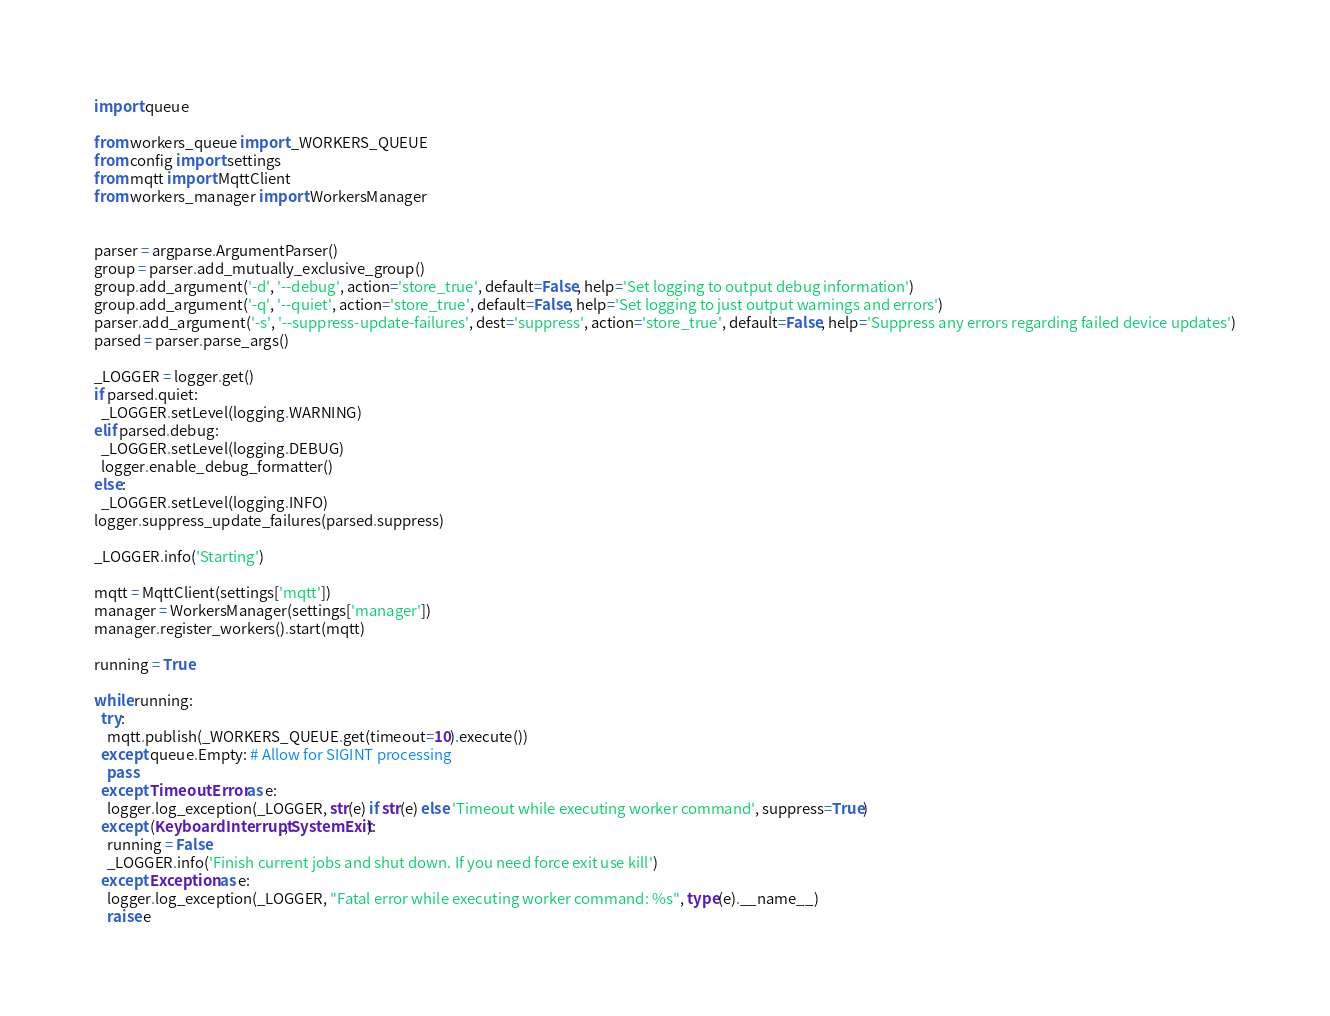<code> <loc_0><loc_0><loc_500><loc_500><_Python_>import queue

from workers_queue import _WORKERS_QUEUE
from config import settings
from mqtt import MqttClient
from workers_manager import WorkersManager


parser = argparse.ArgumentParser()
group = parser.add_mutually_exclusive_group()
group.add_argument('-d', '--debug', action='store_true', default=False, help='Set logging to output debug information')
group.add_argument('-q', '--quiet', action='store_true', default=False, help='Set logging to just output warnings and errors')
parser.add_argument('-s', '--suppress-update-failures', dest='suppress', action='store_true', default=False, help='Suppress any errors regarding failed device updates')
parsed = parser.parse_args()

_LOGGER = logger.get()
if parsed.quiet:
  _LOGGER.setLevel(logging.WARNING)
elif parsed.debug:
  _LOGGER.setLevel(logging.DEBUG)
  logger.enable_debug_formatter()
else:
  _LOGGER.setLevel(logging.INFO)
logger.suppress_update_failures(parsed.suppress)

_LOGGER.info('Starting')

mqtt = MqttClient(settings['mqtt'])
manager = WorkersManager(settings['manager'])
manager.register_workers().start(mqtt)

running = True

while running:
  try:
    mqtt.publish(_WORKERS_QUEUE.get(timeout=10).execute())
  except queue.Empty: # Allow for SIGINT processing
    pass
  except TimeoutError as e:
    logger.log_exception(_LOGGER, str(e) if str(e) else 'Timeout while executing worker command', suppress=True)
  except (KeyboardInterrupt, SystemExit):
    running = False
    _LOGGER.info('Finish current jobs and shut down. If you need force exit use kill')
  except Exception as e:
    logger.log_exception(_LOGGER, "Fatal error while executing worker command: %s", type(e).__name__)
    raise e
</code> 